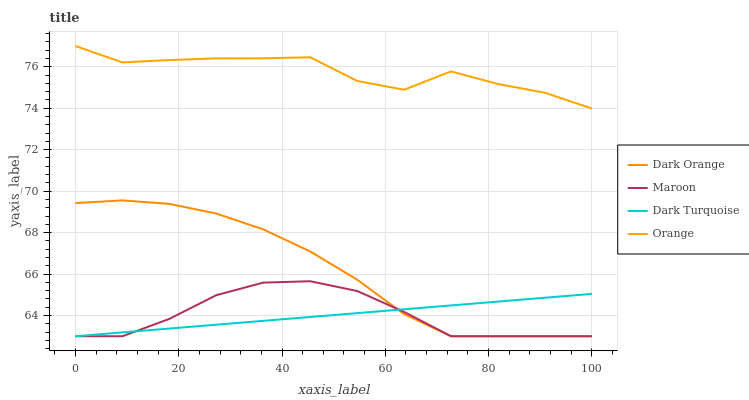Does Dark Turquoise have the minimum area under the curve?
Answer yes or no. Yes. Does Orange have the maximum area under the curve?
Answer yes or no. Yes. Does Dark Orange have the minimum area under the curve?
Answer yes or no. No. Does Dark Orange have the maximum area under the curve?
Answer yes or no. No. Is Dark Turquoise the smoothest?
Answer yes or no. Yes. Is Orange the roughest?
Answer yes or no. Yes. Is Dark Orange the smoothest?
Answer yes or no. No. Is Dark Orange the roughest?
Answer yes or no. No. Does Dark Orange have the lowest value?
Answer yes or no. Yes. Does Orange have the highest value?
Answer yes or no. Yes. Does Dark Orange have the highest value?
Answer yes or no. No. Is Dark Turquoise less than Orange?
Answer yes or no. Yes. Is Orange greater than Maroon?
Answer yes or no. Yes. Does Maroon intersect Dark Orange?
Answer yes or no. Yes. Is Maroon less than Dark Orange?
Answer yes or no. No. Is Maroon greater than Dark Orange?
Answer yes or no. No. Does Dark Turquoise intersect Orange?
Answer yes or no. No. 